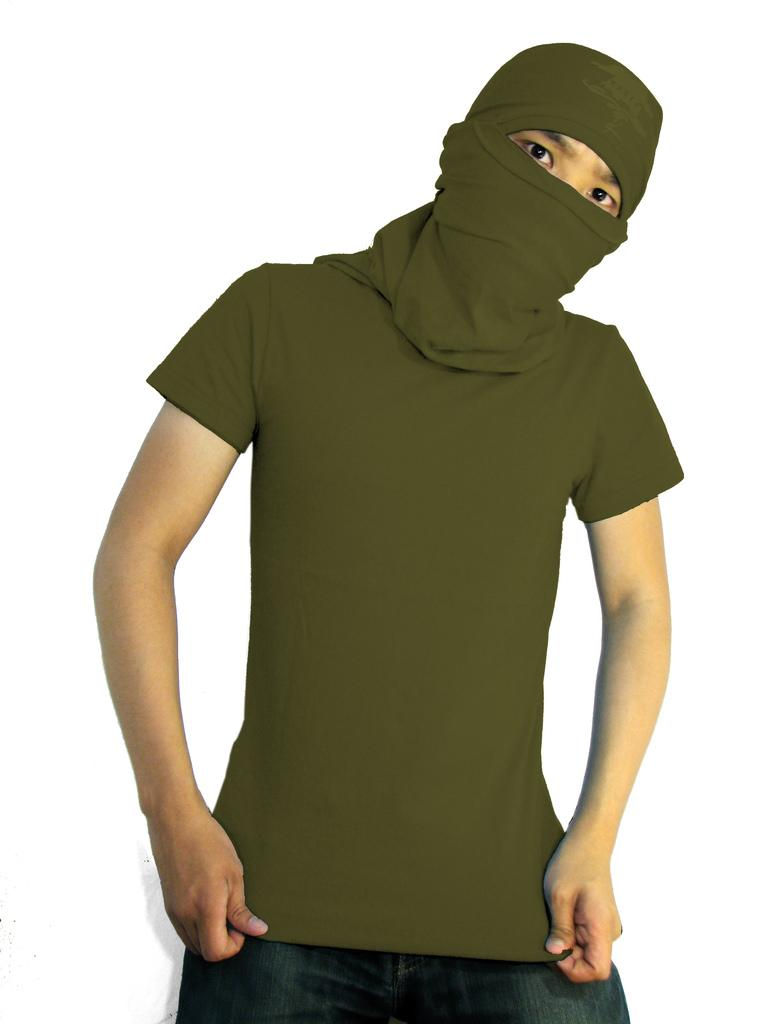Who or what is present in the image? There is a person in the image. What is the person wearing on their head? The person is wearing head-wear. What color is the background of the image? The background of the image is white. What type of news can be heard from the giraffe in the image? There is no giraffe present in the image, and therefore no news can be heard from it. 